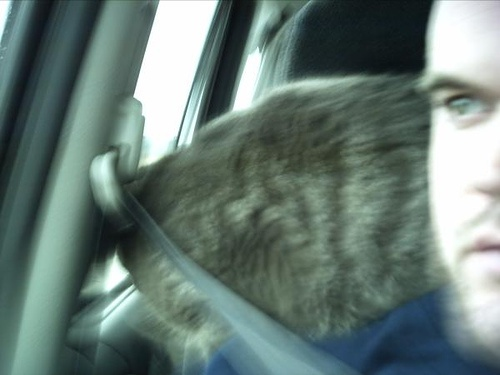Describe the objects in this image and their specific colors. I can see cat in lightgray, gray, and darkgray tones and people in lightgray, white, blue, darkblue, and darkgray tones in this image. 